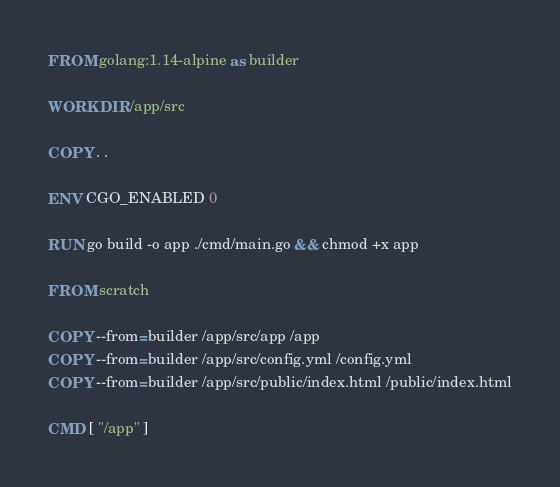Convert code to text. <code><loc_0><loc_0><loc_500><loc_500><_Dockerfile_>FROM golang:1.14-alpine as builder

WORKDIR /app/src

COPY . .

ENV CGO_ENABLED 0

RUN go build -o app ./cmd/main.go && chmod +x app

FROM scratch

COPY --from=builder /app/src/app /app
COPY --from=builder /app/src/config.yml /config.yml
COPY --from=builder /app/src/public/index.html /public/index.html

CMD [ "/app" ]</code> 